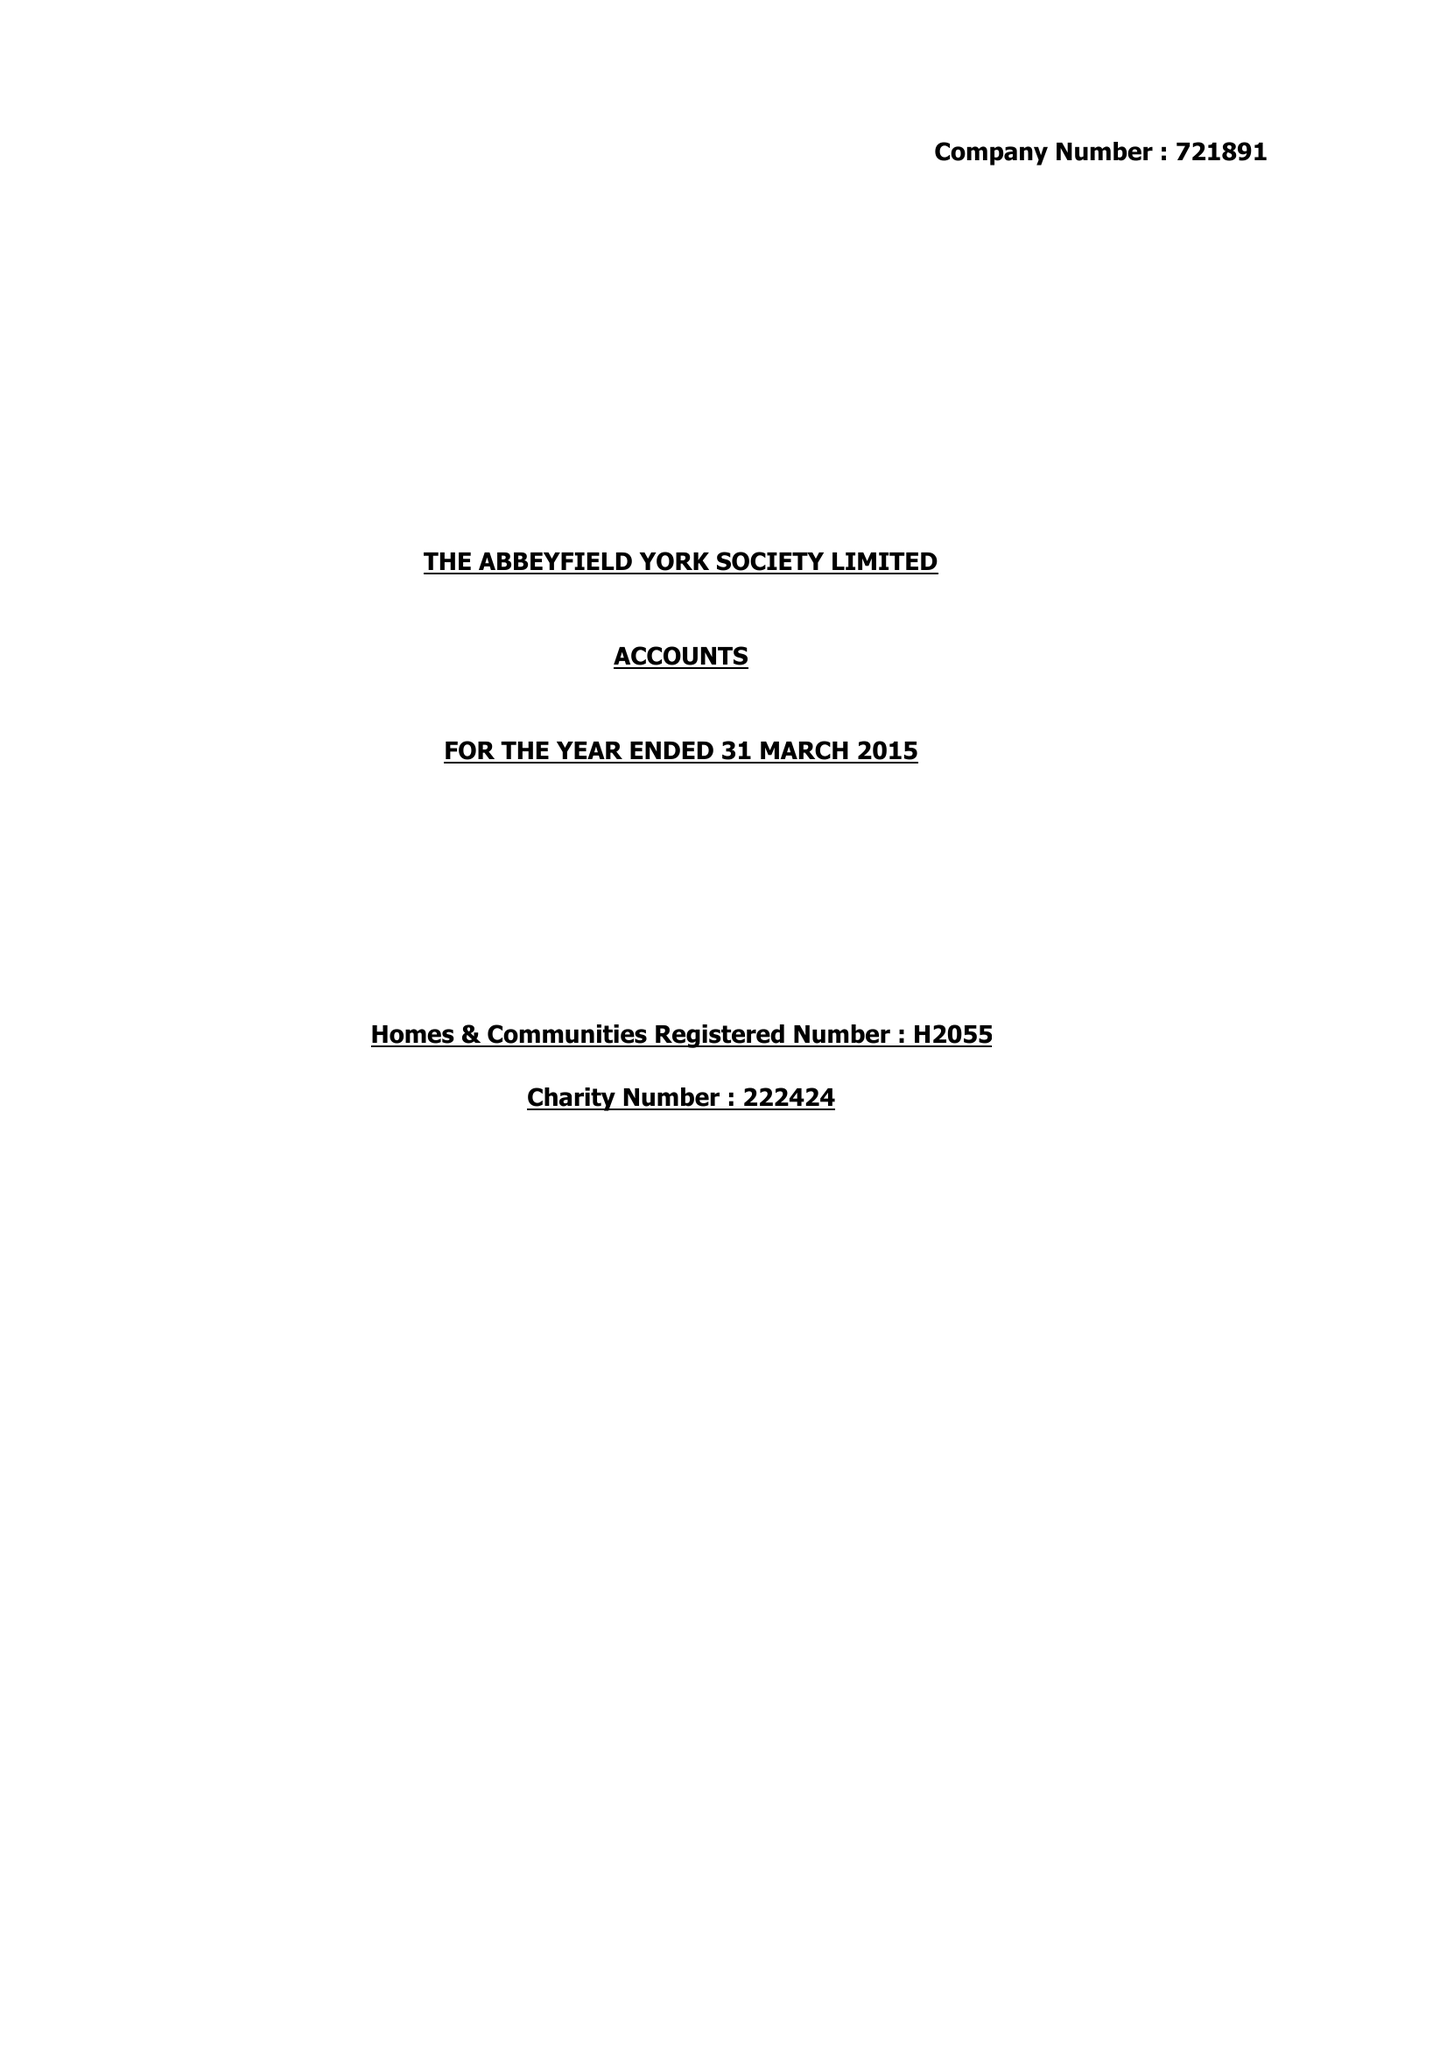What is the value for the charity_number?
Answer the question using a single word or phrase. 222424 